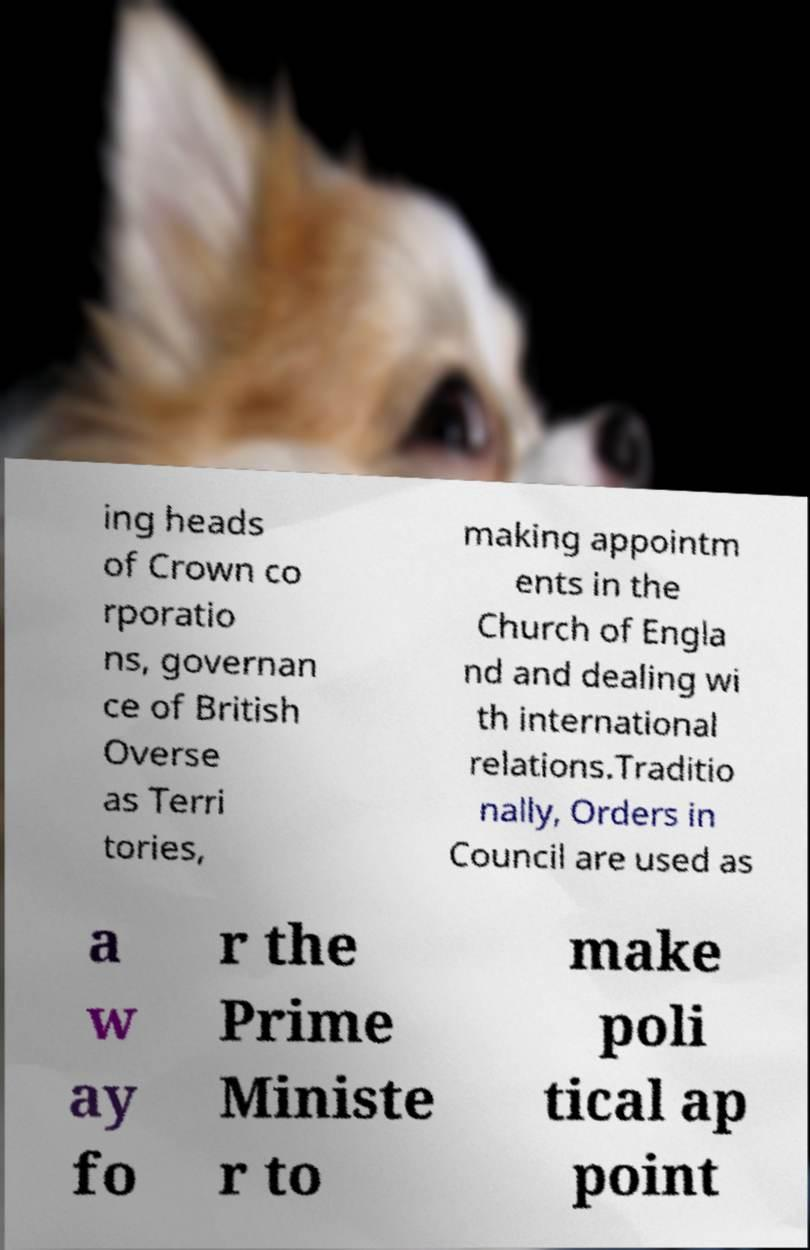There's text embedded in this image that I need extracted. Can you transcribe it verbatim? ing heads of Crown co rporatio ns, governan ce of British Overse as Terri tories, making appointm ents in the Church of Engla nd and dealing wi th international relations.Traditio nally, Orders in Council are used as a w ay fo r the Prime Ministe r to make poli tical ap point 